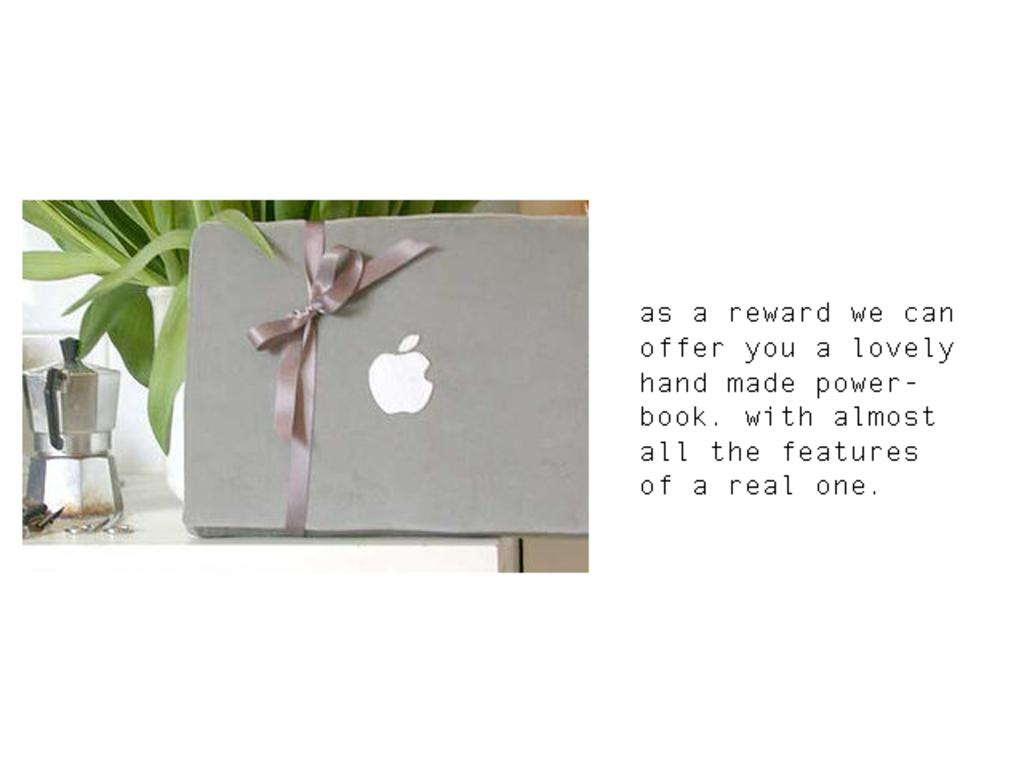<image>
Render a clear and concise summary of the photo. A ribbon wrapped around a box with the Apple company logo on it. 